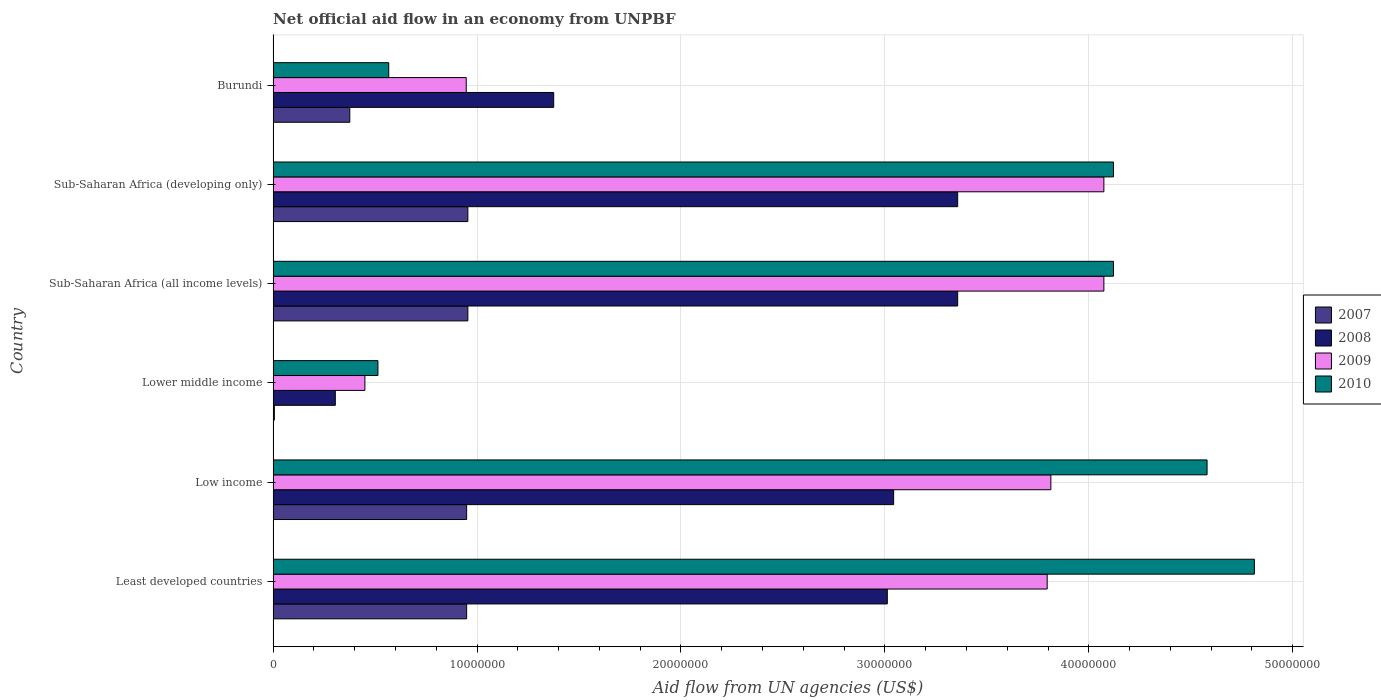Are the number of bars per tick equal to the number of legend labels?
Your response must be concise. Yes. Are the number of bars on each tick of the Y-axis equal?
Your answer should be compact. Yes. How many bars are there on the 4th tick from the top?
Make the answer very short. 4. How many bars are there on the 6th tick from the bottom?
Your answer should be compact. 4. What is the label of the 6th group of bars from the top?
Your answer should be very brief. Least developed countries. What is the net official aid flow in 2007 in Sub-Saharan Africa (developing only)?
Offer a very short reply. 9.55e+06. Across all countries, what is the maximum net official aid flow in 2008?
Your response must be concise. 3.36e+07. Across all countries, what is the minimum net official aid flow in 2009?
Your response must be concise. 4.50e+06. In which country was the net official aid flow in 2010 maximum?
Offer a very short reply. Least developed countries. In which country was the net official aid flow in 2009 minimum?
Your response must be concise. Lower middle income. What is the total net official aid flow in 2009 in the graph?
Your answer should be compact. 1.72e+08. What is the difference between the net official aid flow in 2010 in Lower middle income and that in Sub-Saharan Africa (developing only)?
Your response must be concise. -3.61e+07. What is the difference between the net official aid flow in 2010 in Sub-Saharan Africa (all income levels) and the net official aid flow in 2008 in Least developed countries?
Keep it short and to the point. 1.11e+07. What is the average net official aid flow in 2007 per country?
Provide a succinct answer. 6.98e+06. What is the difference between the net official aid flow in 2007 and net official aid flow in 2009 in Sub-Saharan Africa (developing only)?
Offer a terse response. -3.12e+07. In how many countries, is the net official aid flow in 2009 greater than 20000000 US$?
Your answer should be compact. 4. What is the ratio of the net official aid flow in 2007 in Least developed countries to that in Lower middle income?
Your answer should be very brief. 158.17. Is the net official aid flow in 2009 in Low income less than that in Sub-Saharan Africa (all income levels)?
Your answer should be very brief. Yes. What is the difference between the highest and the lowest net official aid flow in 2008?
Your response must be concise. 3.05e+07. In how many countries, is the net official aid flow in 2007 greater than the average net official aid flow in 2007 taken over all countries?
Offer a very short reply. 4. Is it the case that in every country, the sum of the net official aid flow in 2010 and net official aid flow in 2009 is greater than the sum of net official aid flow in 2007 and net official aid flow in 2008?
Provide a succinct answer. No. What does the 1st bar from the top in Burundi represents?
Provide a succinct answer. 2010. What does the 1st bar from the bottom in Low income represents?
Give a very brief answer. 2007. How many bars are there?
Keep it short and to the point. 24. What is the difference between two consecutive major ticks on the X-axis?
Keep it short and to the point. 1.00e+07. Are the values on the major ticks of X-axis written in scientific E-notation?
Make the answer very short. No. What is the title of the graph?
Provide a succinct answer. Net official aid flow in an economy from UNPBF. What is the label or title of the X-axis?
Ensure brevity in your answer.  Aid flow from UN agencies (US$). What is the label or title of the Y-axis?
Your response must be concise. Country. What is the Aid flow from UN agencies (US$) in 2007 in Least developed countries?
Your response must be concise. 9.49e+06. What is the Aid flow from UN agencies (US$) in 2008 in Least developed countries?
Offer a very short reply. 3.01e+07. What is the Aid flow from UN agencies (US$) of 2009 in Least developed countries?
Your answer should be very brief. 3.80e+07. What is the Aid flow from UN agencies (US$) in 2010 in Least developed countries?
Offer a terse response. 4.81e+07. What is the Aid flow from UN agencies (US$) of 2007 in Low income?
Provide a short and direct response. 9.49e+06. What is the Aid flow from UN agencies (US$) of 2008 in Low income?
Your answer should be very brief. 3.04e+07. What is the Aid flow from UN agencies (US$) of 2009 in Low income?
Give a very brief answer. 3.81e+07. What is the Aid flow from UN agencies (US$) in 2010 in Low income?
Keep it short and to the point. 4.58e+07. What is the Aid flow from UN agencies (US$) of 2008 in Lower middle income?
Your answer should be very brief. 3.05e+06. What is the Aid flow from UN agencies (US$) of 2009 in Lower middle income?
Offer a very short reply. 4.50e+06. What is the Aid flow from UN agencies (US$) in 2010 in Lower middle income?
Keep it short and to the point. 5.14e+06. What is the Aid flow from UN agencies (US$) in 2007 in Sub-Saharan Africa (all income levels)?
Make the answer very short. 9.55e+06. What is the Aid flow from UN agencies (US$) of 2008 in Sub-Saharan Africa (all income levels)?
Your answer should be very brief. 3.36e+07. What is the Aid flow from UN agencies (US$) of 2009 in Sub-Saharan Africa (all income levels)?
Provide a succinct answer. 4.07e+07. What is the Aid flow from UN agencies (US$) in 2010 in Sub-Saharan Africa (all income levels)?
Provide a succinct answer. 4.12e+07. What is the Aid flow from UN agencies (US$) in 2007 in Sub-Saharan Africa (developing only)?
Make the answer very short. 9.55e+06. What is the Aid flow from UN agencies (US$) of 2008 in Sub-Saharan Africa (developing only)?
Provide a succinct answer. 3.36e+07. What is the Aid flow from UN agencies (US$) of 2009 in Sub-Saharan Africa (developing only)?
Give a very brief answer. 4.07e+07. What is the Aid flow from UN agencies (US$) in 2010 in Sub-Saharan Africa (developing only)?
Provide a short and direct response. 4.12e+07. What is the Aid flow from UN agencies (US$) of 2007 in Burundi?
Your answer should be compact. 3.76e+06. What is the Aid flow from UN agencies (US$) of 2008 in Burundi?
Your answer should be compact. 1.38e+07. What is the Aid flow from UN agencies (US$) of 2009 in Burundi?
Ensure brevity in your answer.  9.47e+06. What is the Aid flow from UN agencies (US$) of 2010 in Burundi?
Your answer should be compact. 5.67e+06. Across all countries, what is the maximum Aid flow from UN agencies (US$) in 2007?
Give a very brief answer. 9.55e+06. Across all countries, what is the maximum Aid flow from UN agencies (US$) in 2008?
Offer a terse response. 3.36e+07. Across all countries, what is the maximum Aid flow from UN agencies (US$) of 2009?
Give a very brief answer. 4.07e+07. Across all countries, what is the maximum Aid flow from UN agencies (US$) of 2010?
Give a very brief answer. 4.81e+07. Across all countries, what is the minimum Aid flow from UN agencies (US$) of 2007?
Give a very brief answer. 6.00e+04. Across all countries, what is the minimum Aid flow from UN agencies (US$) in 2008?
Provide a succinct answer. 3.05e+06. Across all countries, what is the minimum Aid flow from UN agencies (US$) in 2009?
Provide a short and direct response. 4.50e+06. Across all countries, what is the minimum Aid flow from UN agencies (US$) in 2010?
Make the answer very short. 5.14e+06. What is the total Aid flow from UN agencies (US$) in 2007 in the graph?
Your answer should be very brief. 4.19e+07. What is the total Aid flow from UN agencies (US$) in 2008 in the graph?
Provide a succinct answer. 1.44e+08. What is the total Aid flow from UN agencies (US$) in 2009 in the graph?
Offer a terse response. 1.72e+08. What is the total Aid flow from UN agencies (US$) in 2010 in the graph?
Give a very brief answer. 1.87e+08. What is the difference between the Aid flow from UN agencies (US$) of 2008 in Least developed countries and that in Low income?
Keep it short and to the point. -3.10e+05. What is the difference between the Aid flow from UN agencies (US$) in 2010 in Least developed countries and that in Low income?
Keep it short and to the point. 2.32e+06. What is the difference between the Aid flow from UN agencies (US$) of 2007 in Least developed countries and that in Lower middle income?
Offer a very short reply. 9.43e+06. What is the difference between the Aid flow from UN agencies (US$) of 2008 in Least developed countries and that in Lower middle income?
Provide a succinct answer. 2.71e+07. What is the difference between the Aid flow from UN agencies (US$) of 2009 in Least developed countries and that in Lower middle income?
Keep it short and to the point. 3.35e+07. What is the difference between the Aid flow from UN agencies (US$) in 2010 in Least developed countries and that in Lower middle income?
Keep it short and to the point. 4.30e+07. What is the difference between the Aid flow from UN agencies (US$) of 2008 in Least developed countries and that in Sub-Saharan Africa (all income levels)?
Make the answer very short. -3.45e+06. What is the difference between the Aid flow from UN agencies (US$) of 2009 in Least developed countries and that in Sub-Saharan Africa (all income levels)?
Your answer should be very brief. -2.78e+06. What is the difference between the Aid flow from UN agencies (US$) in 2010 in Least developed countries and that in Sub-Saharan Africa (all income levels)?
Your answer should be compact. 6.91e+06. What is the difference between the Aid flow from UN agencies (US$) in 2007 in Least developed countries and that in Sub-Saharan Africa (developing only)?
Keep it short and to the point. -6.00e+04. What is the difference between the Aid flow from UN agencies (US$) in 2008 in Least developed countries and that in Sub-Saharan Africa (developing only)?
Make the answer very short. -3.45e+06. What is the difference between the Aid flow from UN agencies (US$) in 2009 in Least developed countries and that in Sub-Saharan Africa (developing only)?
Your response must be concise. -2.78e+06. What is the difference between the Aid flow from UN agencies (US$) of 2010 in Least developed countries and that in Sub-Saharan Africa (developing only)?
Your response must be concise. 6.91e+06. What is the difference between the Aid flow from UN agencies (US$) of 2007 in Least developed countries and that in Burundi?
Ensure brevity in your answer.  5.73e+06. What is the difference between the Aid flow from UN agencies (US$) of 2008 in Least developed countries and that in Burundi?
Your answer should be very brief. 1.64e+07. What is the difference between the Aid flow from UN agencies (US$) of 2009 in Least developed countries and that in Burundi?
Keep it short and to the point. 2.85e+07. What is the difference between the Aid flow from UN agencies (US$) of 2010 in Least developed countries and that in Burundi?
Offer a terse response. 4.24e+07. What is the difference between the Aid flow from UN agencies (US$) of 2007 in Low income and that in Lower middle income?
Offer a terse response. 9.43e+06. What is the difference between the Aid flow from UN agencies (US$) in 2008 in Low income and that in Lower middle income?
Provide a succinct answer. 2.74e+07. What is the difference between the Aid flow from UN agencies (US$) in 2009 in Low income and that in Lower middle income?
Ensure brevity in your answer.  3.36e+07. What is the difference between the Aid flow from UN agencies (US$) of 2010 in Low income and that in Lower middle income?
Offer a terse response. 4.07e+07. What is the difference between the Aid flow from UN agencies (US$) of 2007 in Low income and that in Sub-Saharan Africa (all income levels)?
Make the answer very short. -6.00e+04. What is the difference between the Aid flow from UN agencies (US$) of 2008 in Low income and that in Sub-Saharan Africa (all income levels)?
Keep it short and to the point. -3.14e+06. What is the difference between the Aid flow from UN agencies (US$) in 2009 in Low income and that in Sub-Saharan Africa (all income levels)?
Give a very brief answer. -2.60e+06. What is the difference between the Aid flow from UN agencies (US$) of 2010 in Low income and that in Sub-Saharan Africa (all income levels)?
Keep it short and to the point. 4.59e+06. What is the difference between the Aid flow from UN agencies (US$) in 2007 in Low income and that in Sub-Saharan Africa (developing only)?
Give a very brief answer. -6.00e+04. What is the difference between the Aid flow from UN agencies (US$) in 2008 in Low income and that in Sub-Saharan Africa (developing only)?
Ensure brevity in your answer.  -3.14e+06. What is the difference between the Aid flow from UN agencies (US$) in 2009 in Low income and that in Sub-Saharan Africa (developing only)?
Your answer should be very brief. -2.60e+06. What is the difference between the Aid flow from UN agencies (US$) of 2010 in Low income and that in Sub-Saharan Africa (developing only)?
Provide a succinct answer. 4.59e+06. What is the difference between the Aid flow from UN agencies (US$) of 2007 in Low income and that in Burundi?
Your answer should be compact. 5.73e+06. What is the difference between the Aid flow from UN agencies (US$) in 2008 in Low income and that in Burundi?
Ensure brevity in your answer.  1.67e+07. What is the difference between the Aid flow from UN agencies (US$) of 2009 in Low income and that in Burundi?
Your response must be concise. 2.87e+07. What is the difference between the Aid flow from UN agencies (US$) of 2010 in Low income and that in Burundi?
Keep it short and to the point. 4.01e+07. What is the difference between the Aid flow from UN agencies (US$) in 2007 in Lower middle income and that in Sub-Saharan Africa (all income levels)?
Provide a short and direct response. -9.49e+06. What is the difference between the Aid flow from UN agencies (US$) of 2008 in Lower middle income and that in Sub-Saharan Africa (all income levels)?
Give a very brief answer. -3.05e+07. What is the difference between the Aid flow from UN agencies (US$) in 2009 in Lower middle income and that in Sub-Saharan Africa (all income levels)?
Provide a short and direct response. -3.62e+07. What is the difference between the Aid flow from UN agencies (US$) of 2010 in Lower middle income and that in Sub-Saharan Africa (all income levels)?
Keep it short and to the point. -3.61e+07. What is the difference between the Aid flow from UN agencies (US$) of 2007 in Lower middle income and that in Sub-Saharan Africa (developing only)?
Your response must be concise. -9.49e+06. What is the difference between the Aid flow from UN agencies (US$) of 2008 in Lower middle income and that in Sub-Saharan Africa (developing only)?
Ensure brevity in your answer.  -3.05e+07. What is the difference between the Aid flow from UN agencies (US$) in 2009 in Lower middle income and that in Sub-Saharan Africa (developing only)?
Keep it short and to the point. -3.62e+07. What is the difference between the Aid flow from UN agencies (US$) of 2010 in Lower middle income and that in Sub-Saharan Africa (developing only)?
Offer a terse response. -3.61e+07. What is the difference between the Aid flow from UN agencies (US$) of 2007 in Lower middle income and that in Burundi?
Give a very brief answer. -3.70e+06. What is the difference between the Aid flow from UN agencies (US$) in 2008 in Lower middle income and that in Burundi?
Your answer should be compact. -1.07e+07. What is the difference between the Aid flow from UN agencies (US$) of 2009 in Lower middle income and that in Burundi?
Give a very brief answer. -4.97e+06. What is the difference between the Aid flow from UN agencies (US$) in 2010 in Lower middle income and that in Burundi?
Ensure brevity in your answer.  -5.30e+05. What is the difference between the Aid flow from UN agencies (US$) of 2007 in Sub-Saharan Africa (all income levels) and that in Sub-Saharan Africa (developing only)?
Give a very brief answer. 0. What is the difference between the Aid flow from UN agencies (US$) of 2008 in Sub-Saharan Africa (all income levels) and that in Sub-Saharan Africa (developing only)?
Ensure brevity in your answer.  0. What is the difference between the Aid flow from UN agencies (US$) of 2009 in Sub-Saharan Africa (all income levels) and that in Sub-Saharan Africa (developing only)?
Provide a short and direct response. 0. What is the difference between the Aid flow from UN agencies (US$) of 2007 in Sub-Saharan Africa (all income levels) and that in Burundi?
Your response must be concise. 5.79e+06. What is the difference between the Aid flow from UN agencies (US$) in 2008 in Sub-Saharan Africa (all income levels) and that in Burundi?
Give a very brief answer. 1.98e+07. What is the difference between the Aid flow from UN agencies (US$) of 2009 in Sub-Saharan Africa (all income levels) and that in Burundi?
Provide a succinct answer. 3.13e+07. What is the difference between the Aid flow from UN agencies (US$) of 2010 in Sub-Saharan Africa (all income levels) and that in Burundi?
Give a very brief answer. 3.55e+07. What is the difference between the Aid flow from UN agencies (US$) of 2007 in Sub-Saharan Africa (developing only) and that in Burundi?
Offer a terse response. 5.79e+06. What is the difference between the Aid flow from UN agencies (US$) in 2008 in Sub-Saharan Africa (developing only) and that in Burundi?
Keep it short and to the point. 1.98e+07. What is the difference between the Aid flow from UN agencies (US$) in 2009 in Sub-Saharan Africa (developing only) and that in Burundi?
Your response must be concise. 3.13e+07. What is the difference between the Aid flow from UN agencies (US$) of 2010 in Sub-Saharan Africa (developing only) and that in Burundi?
Provide a short and direct response. 3.55e+07. What is the difference between the Aid flow from UN agencies (US$) in 2007 in Least developed countries and the Aid flow from UN agencies (US$) in 2008 in Low income?
Your answer should be very brief. -2.09e+07. What is the difference between the Aid flow from UN agencies (US$) in 2007 in Least developed countries and the Aid flow from UN agencies (US$) in 2009 in Low income?
Give a very brief answer. -2.86e+07. What is the difference between the Aid flow from UN agencies (US$) of 2007 in Least developed countries and the Aid flow from UN agencies (US$) of 2010 in Low income?
Your answer should be compact. -3.63e+07. What is the difference between the Aid flow from UN agencies (US$) of 2008 in Least developed countries and the Aid flow from UN agencies (US$) of 2009 in Low income?
Provide a short and direct response. -8.02e+06. What is the difference between the Aid flow from UN agencies (US$) in 2008 in Least developed countries and the Aid flow from UN agencies (US$) in 2010 in Low income?
Your answer should be very brief. -1.57e+07. What is the difference between the Aid flow from UN agencies (US$) of 2009 in Least developed countries and the Aid flow from UN agencies (US$) of 2010 in Low income?
Your answer should be compact. -7.84e+06. What is the difference between the Aid flow from UN agencies (US$) of 2007 in Least developed countries and the Aid flow from UN agencies (US$) of 2008 in Lower middle income?
Keep it short and to the point. 6.44e+06. What is the difference between the Aid flow from UN agencies (US$) in 2007 in Least developed countries and the Aid flow from UN agencies (US$) in 2009 in Lower middle income?
Your answer should be very brief. 4.99e+06. What is the difference between the Aid flow from UN agencies (US$) in 2007 in Least developed countries and the Aid flow from UN agencies (US$) in 2010 in Lower middle income?
Offer a very short reply. 4.35e+06. What is the difference between the Aid flow from UN agencies (US$) of 2008 in Least developed countries and the Aid flow from UN agencies (US$) of 2009 in Lower middle income?
Offer a terse response. 2.56e+07. What is the difference between the Aid flow from UN agencies (US$) in 2008 in Least developed countries and the Aid flow from UN agencies (US$) in 2010 in Lower middle income?
Your answer should be very brief. 2.50e+07. What is the difference between the Aid flow from UN agencies (US$) in 2009 in Least developed countries and the Aid flow from UN agencies (US$) in 2010 in Lower middle income?
Your response must be concise. 3.28e+07. What is the difference between the Aid flow from UN agencies (US$) in 2007 in Least developed countries and the Aid flow from UN agencies (US$) in 2008 in Sub-Saharan Africa (all income levels)?
Offer a terse response. -2.41e+07. What is the difference between the Aid flow from UN agencies (US$) in 2007 in Least developed countries and the Aid flow from UN agencies (US$) in 2009 in Sub-Saharan Africa (all income levels)?
Ensure brevity in your answer.  -3.12e+07. What is the difference between the Aid flow from UN agencies (US$) in 2007 in Least developed countries and the Aid flow from UN agencies (US$) in 2010 in Sub-Saharan Africa (all income levels)?
Provide a short and direct response. -3.17e+07. What is the difference between the Aid flow from UN agencies (US$) of 2008 in Least developed countries and the Aid flow from UN agencies (US$) of 2009 in Sub-Saharan Africa (all income levels)?
Your answer should be very brief. -1.06e+07. What is the difference between the Aid flow from UN agencies (US$) in 2008 in Least developed countries and the Aid flow from UN agencies (US$) in 2010 in Sub-Saharan Africa (all income levels)?
Ensure brevity in your answer.  -1.11e+07. What is the difference between the Aid flow from UN agencies (US$) of 2009 in Least developed countries and the Aid flow from UN agencies (US$) of 2010 in Sub-Saharan Africa (all income levels)?
Make the answer very short. -3.25e+06. What is the difference between the Aid flow from UN agencies (US$) of 2007 in Least developed countries and the Aid flow from UN agencies (US$) of 2008 in Sub-Saharan Africa (developing only)?
Keep it short and to the point. -2.41e+07. What is the difference between the Aid flow from UN agencies (US$) in 2007 in Least developed countries and the Aid flow from UN agencies (US$) in 2009 in Sub-Saharan Africa (developing only)?
Offer a terse response. -3.12e+07. What is the difference between the Aid flow from UN agencies (US$) of 2007 in Least developed countries and the Aid flow from UN agencies (US$) of 2010 in Sub-Saharan Africa (developing only)?
Your answer should be compact. -3.17e+07. What is the difference between the Aid flow from UN agencies (US$) of 2008 in Least developed countries and the Aid flow from UN agencies (US$) of 2009 in Sub-Saharan Africa (developing only)?
Ensure brevity in your answer.  -1.06e+07. What is the difference between the Aid flow from UN agencies (US$) of 2008 in Least developed countries and the Aid flow from UN agencies (US$) of 2010 in Sub-Saharan Africa (developing only)?
Offer a terse response. -1.11e+07. What is the difference between the Aid flow from UN agencies (US$) of 2009 in Least developed countries and the Aid flow from UN agencies (US$) of 2010 in Sub-Saharan Africa (developing only)?
Your answer should be very brief. -3.25e+06. What is the difference between the Aid flow from UN agencies (US$) of 2007 in Least developed countries and the Aid flow from UN agencies (US$) of 2008 in Burundi?
Keep it short and to the point. -4.27e+06. What is the difference between the Aid flow from UN agencies (US$) of 2007 in Least developed countries and the Aid flow from UN agencies (US$) of 2009 in Burundi?
Provide a succinct answer. 2.00e+04. What is the difference between the Aid flow from UN agencies (US$) in 2007 in Least developed countries and the Aid flow from UN agencies (US$) in 2010 in Burundi?
Provide a succinct answer. 3.82e+06. What is the difference between the Aid flow from UN agencies (US$) of 2008 in Least developed countries and the Aid flow from UN agencies (US$) of 2009 in Burundi?
Your response must be concise. 2.06e+07. What is the difference between the Aid flow from UN agencies (US$) in 2008 in Least developed countries and the Aid flow from UN agencies (US$) in 2010 in Burundi?
Give a very brief answer. 2.44e+07. What is the difference between the Aid flow from UN agencies (US$) of 2009 in Least developed countries and the Aid flow from UN agencies (US$) of 2010 in Burundi?
Keep it short and to the point. 3.23e+07. What is the difference between the Aid flow from UN agencies (US$) in 2007 in Low income and the Aid flow from UN agencies (US$) in 2008 in Lower middle income?
Provide a short and direct response. 6.44e+06. What is the difference between the Aid flow from UN agencies (US$) of 2007 in Low income and the Aid flow from UN agencies (US$) of 2009 in Lower middle income?
Provide a short and direct response. 4.99e+06. What is the difference between the Aid flow from UN agencies (US$) of 2007 in Low income and the Aid flow from UN agencies (US$) of 2010 in Lower middle income?
Offer a very short reply. 4.35e+06. What is the difference between the Aid flow from UN agencies (US$) in 2008 in Low income and the Aid flow from UN agencies (US$) in 2009 in Lower middle income?
Your answer should be compact. 2.59e+07. What is the difference between the Aid flow from UN agencies (US$) in 2008 in Low income and the Aid flow from UN agencies (US$) in 2010 in Lower middle income?
Give a very brief answer. 2.53e+07. What is the difference between the Aid flow from UN agencies (US$) in 2009 in Low income and the Aid flow from UN agencies (US$) in 2010 in Lower middle income?
Provide a short and direct response. 3.30e+07. What is the difference between the Aid flow from UN agencies (US$) in 2007 in Low income and the Aid flow from UN agencies (US$) in 2008 in Sub-Saharan Africa (all income levels)?
Make the answer very short. -2.41e+07. What is the difference between the Aid flow from UN agencies (US$) of 2007 in Low income and the Aid flow from UN agencies (US$) of 2009 in Sub-Saharan Africa (all income levels)?
Offer a terse response. -3.12e+07. What is the difference between the Aid flow from UN agencies (US$) in 2007 in Low income and the Aid flow from UN agencies (US$) in 2010 in Sub-Saharan Africa (all income levels)?
Your answer should be compact. -3.17e+07. What is the difference between the Aid flow from UN agencies (US$) in 2008 in Low income and the Aid flow from UN agencies (US$) in 2009 in Sub-Saharan Africa (all income levels)?
Provide a succinct answer. -1.03e+07. What is the difference between the Aid flow from UN agencies (US$) of 2008 in Low income and the Aid flow from UN agencies (US$) of 2010 in Sub-Saharan Africa (all income levels)?
Offer a terse response. -1.08e+07. What is the difference between the Aid flow from UN agencies (US$) of 2009 in Low income and the Aid flow from UN agencies (US$) of 2010 in Sub-Saharan Africa (all income levels)?
Make the answer very short. -3.07e+06. What is the difference between the Aid flow from UN agencies (US$) in 2007 in Low income and the Aid flow from UN agencies (US$) in 2008 in Sub-Saharan Africa (developing only)?
Make the answer very short. -2.41e+07. What is the difference between the Aid flow from UN agencies (US$) in 2007 in Low income and the Aid flow from UN agencies (US$) in 2009 in Sub-Saharan Africa (developing only)?
Your answer should be very brief. -3.12e+07. What is the difference between the Aid flow from UN agencies (US$) in 2007 in Low income and the Aid flow from UN agencies (US$) in 2010 in Sub-Saharan Africa (developing only)?
Offer a terse response. -3.17e+07. What is the difference between the Aid flow from UN agencies (US$) in 2008 in Low income and the Aid flow from UN agencies (US$) in 2009 in Sub-Saharan Africa (developing only)?
Make the answer very short. -1.03e+07. What is the difference between the Aid flow from UN agencies (US$) of 2008 in Low income and the Aid flow from UN agencies (US$) of 2010 in Sub-Saharan Africa (developing only)?
Keep it short and to the point. -1.08e+07. What is the difference between the Aid flow from UN agencies (US$) in 2009 in Low income and the Aid flow from UN agencies (US$) in 2010 in Sub-Saharan Africa (developing only)?
Ensure brevity in your answer.  -3.07e+06. What is the difference between the Aid flow from UN agencies (US$) of 2007 in Low income and the Aid flow from UN agencies (US$) of 2008 in Burundi?
Provide a succinct answer. -4.27e+06. What is the difference between the Aid flow from UN agencies (US$) in 2007 in Low income and the Aid flow from UN agencies (US$) in 2010 in Burundi?
Ensure brevity in your answer.  3.82e+06. What is the difference between the Aid flow from UN agencies (US$) in 2008 in Low income and the Aid flow from UN agencies (US$) in 2009 in Burundi?
Your answer should be compact. 2.10e+07. What is the difference between the Aid flow from UN agencies (US$) of 2008 in Low income and the Aid flow from UN agencies (US$) of 2010 in Burundi?
Offer a terse response. 2.48e+07. What is the difference between the Aid flow from UN agencies (US$) in 2009 in Low income and the Aid flow from UN agencies (US$) in 2010 in Burundi?
Offer a very short reply. 3.25e+07. What is the difference between the Aid flow from UN agencies (US$) in 2007 in Lower middle income and the Aid flow from UN agencies (US$) in 2008 in Sub-Saharan Africa (all income levels)?
Your answer should be compact. -3.35e+07. What is the difference between the Aid flow from UN agencies (US$) of 2007 in Lower middle income and the Aid flow from UN agencies (US$) of 2009 in Sub-Saharan Africa (all income levels)?
Provide a short and direct response. -4.07e+07. What is the difference between the Aid flow from UN agencies (US$) of 2007 in Lower middle income and the Aid flow from UN agencies (US$) of 2010 in Sub-Saharan Africa (all income levels)?
Provide a short and direct response. -4.12e+07. What is the difference between the Aid flow from UN agencies (US$) of 2008 in Lower middle income and the Aid flow from UN agencies (US$) of 2009 in Sub-Saharan Africa (all income levels)?
Offer a very short reply. -3.77e+07. What is the difference between the Aid flow from UN agencies (US$) of 2008 in Lower middle income and the Aid flow from UN agencies (US$) of 2010 in Sub-Saharan Africa (all income levels)?
Offer a very short reply. -3.82e+07. What is the difference between the Aid flow from UN agencies (US$) of 2009 in Lower middle income and the Aid flow from UN agencies (US$) of 2010 in Sub-Saharan Africa (all income levels)?
Give a very brief answer. -3.67e+07. What is the difference between the Aid flow from UN agencies (US$) of 2007 in Lower middle income and the Aid flow from UN agencies (US$) of 2008 in Sub-Saharan Africa (developing only)?
Make the answer very short. -3.35e+07. What is the difference between the Aid flow from UN agencies (US$) of 2007 in Lower middle income and the Aid flow from UN agencies (US$) of 2009 in Sub-Saharan Africa (developing only)?
Keep it short and to the point. -4.07e+07. What is the difference between the Aid flow from UN agencies (US$) in 2007 in Lower middle income and the Aid flow from UN agencies (US$) in 2010 in Sub-Saharan Africa (developing only)?
Your answer should be very brief. -4.12e+07. What is the difference between the Aid flow from UN agencies (US$) of 2008 in Lower middle income and the Aid flow from UN agencies (US$) of 2009 in Sub-Saharan Africa (developing only)?
Provide a short and direct response. -3.77e+07. What is the difference between the Aid flow from UN agencies (US$) of 2008 in Lower middle income and the Aid flow from UN agencies (US$) of 2010 in Sub-Saharan Africa (developing only)?
Offer a very short reply. -3.82e+07. What is the difference between the Aid flow from UN agencies (US$) of 2009 in Lower middle income and the Aid flow from UN agencies (US$) of 2010 in Sub-Saharan Africa (developing only)?
Give a very brief answer. -3.67e+07. What is the difference between the Aid flow from UN agencies (US$) of 2007 in Lower middle income and the Aid flow from UN agencies (US$) of 2008 in Burundi?
Give a very brief answer. -1.37e+07. What is the difference between the Aid flow from UN agencies (US$) in 2007 in Lower middle income and the Aid flow from UN agencies (US$) in 2009 in Burundi?
Ensure brevity in your answer.  -9.41e+06. What is the difference between the Aid flow from UN agencies (US$) of 2007 in Lower middle income and the Aid flow from UN agencies (US$) of 2010 in Burundi?
Provide a short and direct response. -5.61e+06. What is the difference between the Aid flow from UN agencies (US$) of 2008 in Lower middle income and the Aid flow from UN agencies (US$) of 2009 in Burundi?
Your answer should be very brief. -6.42e+06. What is the difference between the Aid flow from UN agencies (US$) of 2008 in Lower middle income and the Aid flow from UN agencies (US$) of 2010 in Burundi?
Give a very brief answer. -2.62e+06. What is the difference between the Aid flow from UN agencies (US$) in 2009 in Lower middle income and the Aid flow from UN agencies (US$) in 2010 in Burundi?
Provide a succinct answer. -1.17e+06. What is the difference between the Aid flow from UN agencies (US$) in 2007 in Sub-Saharan Africa (all income levels) and the Aid flow from UN agencies (US$) in 2008 in Sub-Saharan Africa (developing only)?
Your answer should be very brief. -2.40e+07. What is the difference between the Aid flow from UN agencies (US$) of 2007 in Sub-Saharan Africa (all income levels) and the Aid flow from UN agencies (US$) of 2009 in Sub-Saharan Africa (developing only)?
Provide a short and direct response. -3.12e+07. What is the difference between the Aid flow from UN agencies (US$) in 2007 in Sub-Saharan Africa (all income levels) and the Aid flow from UN agencies (US$) in 2010 in Sub-Saharan Africa (developing only)?
Offer a terse response. -3.17e+07. What is the difference between the Aid flow from UN agencies (US$) of 2008 in Sub-Saharan Africa (all income levels) and the Aid flow from UN agencies (US$) of 2009 in Sub-Saharan Africa (developing only)?
Offer a very short reply. -7.17e+06. What is the difference between the Aid flow from UN agencies (US$) of 2008 in Sub-Saharan Africa (all income levels) and the Aid flow from UN agencies (US$) of 2010 in Sub-Saharan Africa (developing only)?
Provide a short and direct response. -7.64e+06. What is the difference between the Aid flow from UN agencies (US$) in 2009 in Sub-Saharan Africa (all income levels) and the Aid flow from UN agencies (US$) in 2010 in Sub-Saharan Africa (developing only)?
Your answer should be very brief. -4.70e+05. What is the difference between the Aid flow from UN agencies (US$) of 2007 in Sub-Saharan Africa (all income levels) and the Aid flow from UN agencies (US$) of 2008 in Burundi?
Provide a succinct answer. -4.21e+06. What is the difference between the Aid flow from UN agencies (US$) in 2007 in Sub-Saharan Africa (all income levels) and the Aid flow from UN agencies (US$) in 2010 in Burundi?
Your answer should be very brief. 3.88e+06. What is the difference between the Aid flow from UN agencies (US$) in 2008 in Sub-Saharan Africa (all income levels) and the Aid flow from UN agencies (US$) in 2009 in Burundi?
Your answer should be compact. 2.41e+07. What is the difference between the Aid flow from UN agencies (US$) of 2008 in Sub-Saharan Africa (all income levels) and the Aid flow from UN agencies (US$) of 2010 in Burundi?
Provide a succinct answer. 2.79e+07. What is the difference between the Aid flow from UN agencies (US$) in 2009 in Sub-Saharan Africa (all income levels) and the Aid flow from UN agencies (US$) in 2010 in Burundi?
Offer a terse response. 3.51e+07. What is the difference between the Aid flow from UN agencies (US$) of 2007 in Sub-Saharan Africa (developing only) and the Aid flow from UN agencies (US$) of 2008 in Burundi?
Provide a short and direct response. -4.21e+06. What is the difference between the Aid flow from UN agencies (US$) in 2007 in Sub-Saharan Africa (developing only) and the Aid flow from UN agencies (US$) in 2009 in Burundi?
Provide a short and direct response. 8.00e+04. What is the difference between the Aid flow from UN agencies (US$) in 2007 in Sub-Saharan Africa (developing only) and the Aid flow from UN agencies (US$) in 2010 in Burundi?
Offer a very short reply. 3.88e+06. What is the difference between the Aid flow from UN agencies (US$) of 2008 in Sub-Saharan Africa (developing only) and the Aid flow from UN agencies (US$) of 2009 in Burundi?
Keep it short and to the point. 2.41e+07. What is the difference between the Aid flow from UN agencies (US$) of 2008 in Sub-Saharan Africa (developing only) and the Aid flow from UN agencies (US$) of 2010 in Burundi?
Your response must be concise. 2.79e+07. What is the difference between the Aid flow from UN agencies (US$) in 2009 in Sub-Saharan Africa (developing only) and the Aid flow from UN agencies (US$) in 2010 in Burundi?
Your response must be concise. 3.51e+07. What is the average Aid flow from UN agencies (US$) of 2007 per country?
Give a very brief answer. 6.98e+06. What is the average Aid flow from UN agencies (US$) in 2008 per country?
Your response must be concise. 2.41e+07. What is the average Aid flow from UN agencies (US$) in 2009 per country?
Give a very brief answer. 2.86e+07. What is the average Aid flow from UN agencies (US$) in 2010 per country?
Provide a short and direct response. 3.12e+07. What is the difference between the Aid flow from UN agencies (US$) in 2007 and Aid flow from UN agencies (US$) in 2008 in Least developed countries?
Keep it short and to the point. -2.06e+07. What is the difference between the Aid flow from UN agencies (US$) in 2007 and Aid flow from UN agencies (US$) in 2009 in Least developed countries?
Your answer should be compact. -2.85e+07. What is the difference between the Aid flow from UN agencies (US$) of 2007 and Aid flow from UN agencies (US$) of 2010 in Least developed countries?
Provide a short and direct response. -3.86e+07. What is the difference between the Aid flow from UN agencies (US$) in 2008 and Aid flow from UN agencies (US$) in 2009 in Least developed countries?
Your answer should be compact. -7.84e+06. What is the difference between the Aid flow from UN agencies (US$) in 2008 and Aid flow from UN agencies (US$) in 2010 in Least developed countries?
Ensure brevity in your answer.  -1.80e+07. What is the difference between the Aid flow from UN agencies (US$) of 2009 and Aid flow from UN agencies (US$) of 2010 in Least developed countries?
Offer a very short reply. -1.02e+07. What is the difference between the Aid flow from UN agencies (US$) in 2007 and Aid flow from UN agencies (US$) in 2008 in Low income?
Make the answer very short. -2.09e+07. What is the difference between the Aid flow from UN agencies (US$) of 2007 and Aid flow from UN agencies (US$) of 2009 in Low income?
Your answer should be compact. -2.86e+07. What is the difference between the Aid flow from UN agencies (US$) in 2007 and Aid flow from UN agencies (US$) in 2010 in Low income?
Offer a terse response. -3.63e+07. What is the difference between the Aid flow from UN agencies (US$) in 2008 and Aid flow from UN agencies (US$) in 2009 in Low income?
Offer a terse response. -7.71e+06. What is the difference between the Aid flow from UN agencies (US$) of 2008 and Aid flow from UN agencies (US$) of 2010 in Low income?
Provide a succinct answer. -1.54e+07. What is the difference between the Aid flow from UN agencies (US$) in 2009 and Aid flow from UN agencies (US$) in 2010 in Low income?
Provide a succinct answer. -7.66e+06. What is the difference between the Aid flow from UN agencies (US$) of 2007 and Aid flow from UN agencies (US$) of 2008 in Lower middle income?
Offer a very short reply. -2.99e+06. What is the difference between the Aid flow from UN agencies (US$) in 2007 and Aid flow from UN agencies (US$) in 2009 in Lower middle income?
Keep it short and to the point. -4.44e+06. What is the difference between the Aid flow from UN agencies (US$) in 2007 and Aid flow from UN agencies (US$) in 2010 in Lower middle income?
Your answer should be compact. -5.08e+06. What is the difference between the Aid flow from UN agencies (US$) in 2008 and Aid flow from UN agencies (US$) in 2009 in Lower middle income?
Your answer should be very brief. -1.45e+06. What is the difference between the Aid flow from UN agencies (US$) of 2008 and Aid flow from UN agencies (US$) of 2010 in Lower middle income?
Offer a terse response. -2.09e+06. What is the difference between the Aid flow from UN agencies (US$) in 2009 and Aid flow from UN agencies (US$) in 2010 in Lower middle income?
Offer a terse response. -6.40e+05. What is the difference between the Aid flow from UN agencies (US$) of 2007 and Aid flow from UN agencies (US$) of 2008 in Sub-Saharan Africa (all income levels)?
Offer a terse response. -2.40e+07. What is the difference between the Aid flow from UN agencies (US$) in 2007 and Aid flow from UN agencies (US$) in 2009 in Sub-Saharan Africa (all income levels)?
Offer a very short reply. -3.12e+07. What is the difference between the Aid flow from UN agencies (US$) in 2007 and Aid flow from UN agencies (US$) in 2010 in Sub-Saharan Africa (all income levels)?
Your answer should be compact. -3.17e+07. What is the difference between the Aid flow from UN agencies (US$) in 2008 and Aid flow from UN agencies (US$) in 2009 in Sub-Saharan Africa (all income levels)?
Keep it short and to the point. -7.17e+06. What is the difference between the Aid flow from UN agencies (US$) of 2008 and Aid flow from UN agencies (US$) of 2010 in Sub-Saharan Africa (all income levels)?
Provide a short and direct response. -7.64e+06. What is the difference between the Aid flow from UN agencies (US$) of 2009 and Aid flow from UN agencies (US$) of 2010 in Sub-Saharan Africa (all income levels)?
Your answer should be very brief. -4.70e+05. What is the difference between the Aid flow from UN agencies (US$) in 2007 and Aid flow from UN agencies (US$) in 2008 in Sub-Saharan Africa (developing only)?
Make the answer very short. -2.40e+07. What is the difference between the Aid flow from UN agencies (US$) in 2007 and Aid flow from UN agencies (US$) in 2009 in Sub-Saharan Africa (developing only)?
Offer a very short reply. -3.12e+07. What is the difference between the Aid flow from UN agencies (US$) in 2007 and Aid flow from UN agencies (US$) in 2010 in Sub-Saharan Africa (developing only)?
Offer a terse response. -3.17e+07. What is the difference between the Aid flow from UN agencies (US$) of 2008 and Aid flow from UN agencies (US$) of 2009 in Sub-Saharan Africa (developing only)?
Make the answer very short. -7.17e+06. What is the difference between the Aid flow from UN agencies (US$) in 2008 and Aid flow from UN agencies (US$) in 2010 in Sub-Saharan Africa (developing only)?
Give a very brief answer. -7.64e+06. What is the difference between the Aid flow from UN agencies (US$) of 2009 and Aid flow from UN agencies (US$) of 2010 in Sub-Saharan Africa (developing only)?
Make the answer very short. -4.70e+05. What is the difference between the Aid flow from UN agencies (US$) of 2007 and Aid flow from UN agencies (US$) of 2008 in Burundi?
Provide a short and direct response. -1.00e+07. What is the difference between the Aid flow from UN agencies (US$) in 2007 and Aid flow from UN agencies (US$) in 2009 in Burundi?
Your answer should be compact. -5.71e+06. What is the difference between the Aid flow from UN agencies (US$) of 2007 and Aid flow from UN agencies (US$) of 2010 in Burundi?
Provide a short and direct response. -1.91e+06. What is the difference between the Aid flow from UN agencies (US$) in 2008 and Aid flow from UN agencies (US$) in 2009 in Burundi?
Your answer should be compact. 4.29e+06. What is the difference between the Aid flow from UN agencies (US$) in 2008 and Aid flow from UN agencies (US$) in 2010 in Burundi?
Your answer should be very brief. 8.09e+06. What is the difference between the Aid flow from UN agencies (US$) in 2009 and Aid flow from UN agencies (US$) in 2010 in Burundi?
Offer a very short reply. 3.80e+06. What is the ratio of the Aid flow from UN agencies (US$) in 2008 in Least developed countries to that in Low income?
Your answer should be very brief. 0.99. What is the ratio of the Aid flow from UN agencies (US$) of 2010 in Least developed countries to that in Low income?
Your answer should be very brief. 1.05. What is the ratio of the Aid flow from UN agencies (US$) in 2007 in Least developed countries to that in Lower middle income?
Offer a terse response. 158.17. What is the ratio of the Aid flow from UN agencies (US$) in 2008 in Least developed countries to that in Lower middle income?
Provide a short and direct response. 9.88. What is the ratio of the Aid flow from UN agencies (US$) in 2009 in Least developed countries to that in Lower middle income?
Make the answer very short. 8.44. What is the ratio of the Aid flow from UN agencies (US$) of 2010 in Least developed countries to that in Lower middle income?
Offer a very short reply. 9.36. What is the ratio of the Aid flow from UN agencies (US$) in 2007 in Least developed countries to that in Sub-Saharan Africa (all income levels)?
Ensure brevity in your answer.  0.99. What is the ratio of the Aid flow from UN agencies (US$) of 2008 in Least developed countries to that in Sub-Saharan Africa (all income levels)?
Give a very brief answer. 0.9. What is the ratio of the Aid flow from UN agencies (US$) of 2009 in Least developed countries to that in Sub-Saharan Africa (all income levels)?
Your answer should be compact. 0.93. What is the ratio of the Aid flow from UN agencies (US$) in 2010 in Least developed countries to that in Sub-Saharan Africa (all income levels)?
Ensure brevity in your answer.  1.17. What is the ratio of the Aid flow from UN agencies (US$) in 2007 in Least developed countries to that in Sub-Saharan Africa (developing only)?
Provide a short and direct response. 0.99. What is the ratio of the Aid flow from UN agencies (US$) of 2008 in Least developed countries to that in Sub-Saharan Africa (developing only)?
Your response must be concise. 0.9. What is the ratio of the Aid flow from UN agencies (US$) of 2009 in Least developed countries to that in Sub-Saharan Africa (developing only)?
Keep it short and to the point. 0.93. What is the ratio of the Aid flow from UN agencies (US$) in 2010 in Least developed countries to that in Sub-Saharan Africa (developing only)?
Make the answer very short. 1.17. What is the ratio of the Aid flow from UN agencies (US$) of 2007 in Least developed countries to that in Burundi?
Offer a terse response. 2.52. What is the ratio of the Aid flow from UN agencies (US$) of 2008 in Least developed countries to that in Burundi?
Make the answer very short. 2.19. What is the ratio of the Aid flow from UN agencies (US$) of 2009 in Least developed countries to that in Burundi?
Offer a terse response. 4.01. What is the ratio of the Aid flow from UN agencies (US$) of 2010 in Least developed countries to that in Burundi?
Ensure brevity in your answer.  8.49. What is the ratio of the Aid flow from UN agencies (US$) of 2007 in Low income to that in Lower middle income?
Provide a succinct answer. 158.17. What is the ratio of the Aid flow from UN agencies (US$) of 2008 in Low income to that in Lower middle income?
Give a very brief answer. 9.98. What is the ratio of the Aid flow from UN agencies (US$) in 2009 in Low income to that in Lower middle income?
Your answer should be very brief. 8.48. What is the ratio of the Aid flow from UN agencies (US$) in 2010 in Low income to that in Lower middle income?
Offer a terse response. 8.91. What is the ratio of the Aid flow from UN agencies (US$) of 2007 in Low income to that in Sub-Saharan Africa (all income levels)?
Provide a short and direct response. 0.99. What is the ratio of the Aid flow from UN agencies (US$) of 2008 in Low income to that in Sub-Saharan Africa (all income levels)?
Provide a succinct answer. 0.91. What is the ratio of the Aid flow from UN agencies (US$) in 2009 in Low income to that in Sub-Saharan Africa (all income levels)?
Ensure brevity in your answer.  0.94. What is the ratio of the Aid flow from UN agencies (US$) in 2010 in Low income to that in Sub-Saharan Africa (all income levels)?
Offer a terse response. 1.11. What is the ratio of the Aid flow from UN agencies (US$) in 2008 in Low income to that in Sub-Saharan Africa (developing only)?
Keep it short and to the point. 0.91. What is the ratio of the Aid flow from UN agencies (US$) of 2009 in Low income to that in Sub-Saharan Africa (developing only)?
Offer a very short reply. 0.94. What is the ratio of the Aid flow from UN agencies (US$) of 2010 in Low income to that in Sub-Saharan Africa (developing only)?
Your answer should be compact. 1.11. What is the ratio of the Aid flow from UN agencies (US$) of 2007 in Low income to that in Burundi?
Keep it short and to the point. 2.52. What is the ratio of the Aid flow from UN agencies (US$) in 2008 in Low income to that in Burundi?
Your response must be concise. 2.21. What is the ratio of the Aid flow from UN agencies (US$) in 2009 in Low income to that in Burundi?
Provide a succinct answer. 4.03. What is the ratio of the Aid flow from UN agencies (US$) of 2010 in Low income to that in Burundi?
Provide a short and direct response. 8.08. What is the ratio of the Aid flow from UN agencies (US$) of 2007 in Lower middle income to that in Sub-Saharan Africa (all income levels)?
Keep it short and to the point. 0.01. What is the ratio of the Aid flow from UN agencies (US$) of 2008 in Lower middle income to that in Sub-Saharan Africa (all income levels)?
Provide a short and direct response. 0.09. What is the ratio of the Aid flow from UN agencies (US$) in 2009 in Lower middle income to that in Sub-Saharan Africa (all income levels)?
Provide a short and direct response. 0.11. What is the ratio of the Aid flow from UN agencies (US$) in 2010 in Lower middle income to that in Sub-Saharan Africa (all income levels)?
Your answer should be very brief. 0.12. What is the ratio of the Aid flow from UN agencies (US$) in 2007 in Lower middle income to that in Sub-Saharan Africa (developing only)?
Your response must be concise. 0.01. What is the ratio of the Aid flow from UN agencies (US$) of 2008 in Lower middle income to that in Sub-Saharan Africa (developing only)?
Provide a short and direct response. 0.09. What is the ratio of the Aid flow from UN agencies (US$) of 2009 in Lower middle income to that in Sub-Saharan Africa (developing only)?
Offer a very short reply. 0.11. What is the ratio of the Aid flow from UN agencies (US$) of 2010 in Lower middle income to that in Sub-Saharan Africa (developing only)?
Offer a terse response. 0.12. What is the ratio of the Aid flow from UN agencies (US$) of 2007 in Lower middle income to that in Burundi?
Offer a terse response. 0.02. What is the ratio of the Aid flow from UN agencies (US$) in 2008 in Lower middle income to that in Burundi?
Ensure brevity in your answer.  0.22. What is the ratio of the Aid flow from UN agencies (US$) of 2009 in Lower middle income to that in Burundi?
Provide a short and direct response. 0.48. What is the ratio of the Aid flow from UN agencies (US$) in 2010 in Lower middle income to that in Burundi?
Make the answer very short. 0.91. What is the ratio of the Aid flow from UN agencies (US$) in 2008 in Sub-Saharan Africa (all income levels) to that in Sub-Saharan Africa (developing only)?
Keep it short and to the point. 1. What is the ratio of the Aid flow from UN agencies (US$) of 2009 in Sub-Saharan Africa (all income levels) to that in Sub-Saharan Africa (developing only)?
Offer a very short reply. 1. What is the ratio of the Aid flow from UN agencies (US$) in 2007 in Sub-Saharan Africa (all income levels) to that in Burundi?
Your answer should be very brief. 2.54. What is the ratio of the Aid flow from UN agencies (US$) of 2008 in Sub-Saharan Africa (all income levels) to that in Burundi?
Your response must be concise. 2.44. What is the ratio of the Aid flow from UN agencies (US$) of 2009 in Sub-Saharan Africa (all income levels) to that in Burundi?
Make the answer very short. 4.3. What is the ratio of the Aid flow from UN agencies (US$) in 2010 in Sub-Saharan Africa (all income levels) to that in Burundi?
Provide a short and direct response. 7.27. What is the ratio of the Aid flow from UN agencies (US$) of 2007 in Sub-Saharan Africa (developing only) to that in Burundi?
Give a very brief answer. 2.54. What is the ratio of the Aid flow from UN agencies (US$) of 2008 in Sub-Saharan Africa (developing only) to that in Burundi?
Provide a succinct answer. 2.44. What is the ratio of the Aid flow from UN agencies (US$) of 2009 in Sub-Saharan Africa (developing only) to that in Burundi?
Your response must be concise. 4.3. What is the ratio of the Aid flow from UN agencies (US$) in 2010 in Sub-Saharan Africa (developing only) to that in Burundi?
Your response must be concise. 7.27. What is the difference between the highest and the second highest Aid flow from UN agencies (US$) in 2010?
Ensure brevity in your answer.  2.32e+06. What is the difference between the highest and the lowest Aid flow from UN agencies (US$) in 2007?
Give a very brief answer. 9.49e+06. What is the difference between the highest and the lowest Aid flow from UN agencies (US$) in 2008?
Make the answer very short. 3.05e+07. What is the difference between the highest and the lowest Aid flow from UN agencies (US$) in 2009?
Your response must be concise. 3.62e+07. What is the difference between the highest and the lowest Aid flow from UN agencies (US$) of 2010?
Make the answer very short. 4.30e+07. 